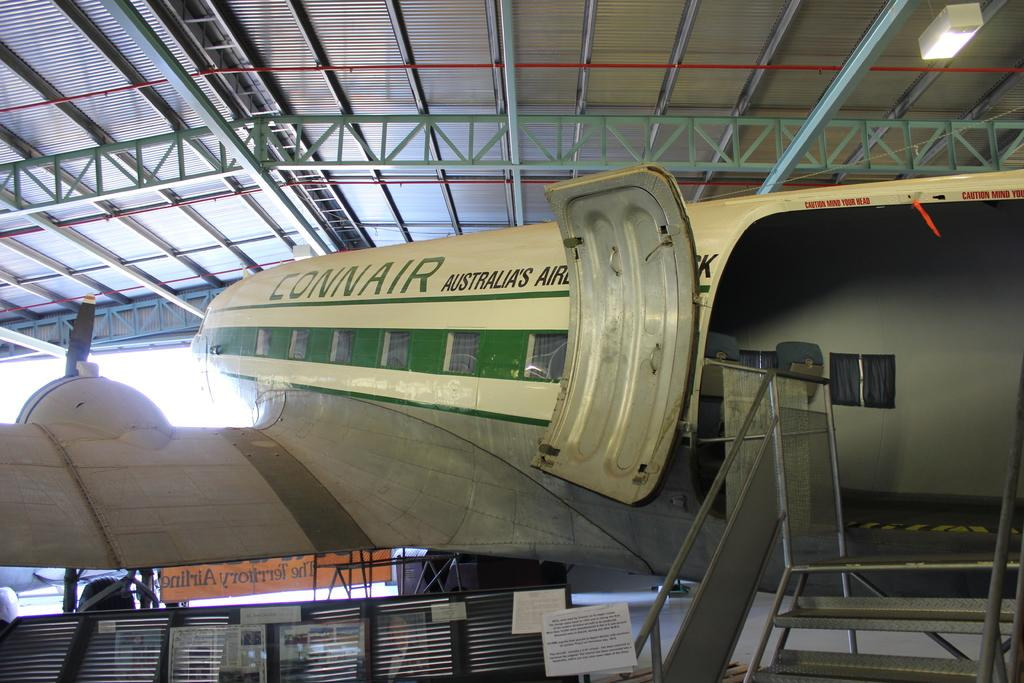Provide a one-sentence caption for the provided image. A Connair plane has its doors open in a hangar. 